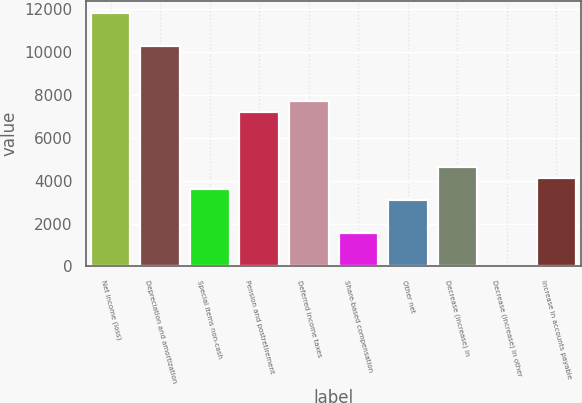Convert chart. <chart><loc_0><loc_0><loc_500><loc_500><bar_chart><fcel>Net income (loss)<fcel>Depreciation and amortization<fcel>Special items non-cash<fcel>Pension and postretirement<fcel>Deferred income taxes<fcel>Share-based compensation<fcel>Other net<fcel>Decrease (increase) in<fcel>Decrease (increase) in other<fcel>Increase in accounts payable<nl><fcel>11806.9<fcel>10267<fcel>3594.1<fcel>7187.2<fcel>7700.5<fcel>1540.9<fcel>3080.8<fcel>4620.7<fcel>1<fcel>4107.4<nl></chart> 